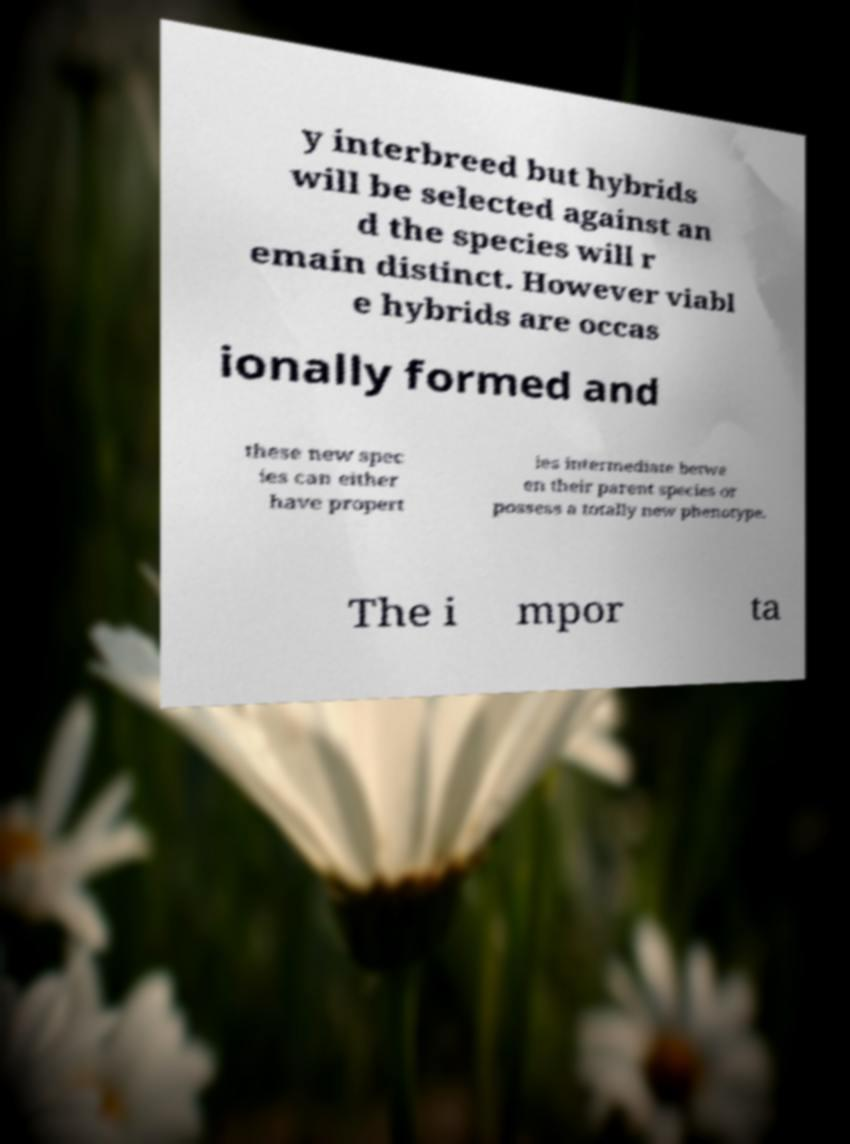What messages or text are displayed in this image? I need them in a readable, typed format. y interbreed but hybrids will be selected against an d the species will r emain distinct. However viabl e hybrids are occas ionally formed and these new spec ies can either have propert ies intermediate betwe en their parent species or possess a totally new phenotype. The i mpor ta 